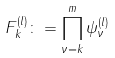Convert formula to latex. <formula><loc_0><loc_0><loc_500><loc_500>F _ { k } ^ { ( l ) } \colon = \prod _ { \nu = k } ^ { m } \psi _ { \nu } ^ { ( l ) }</formula> 